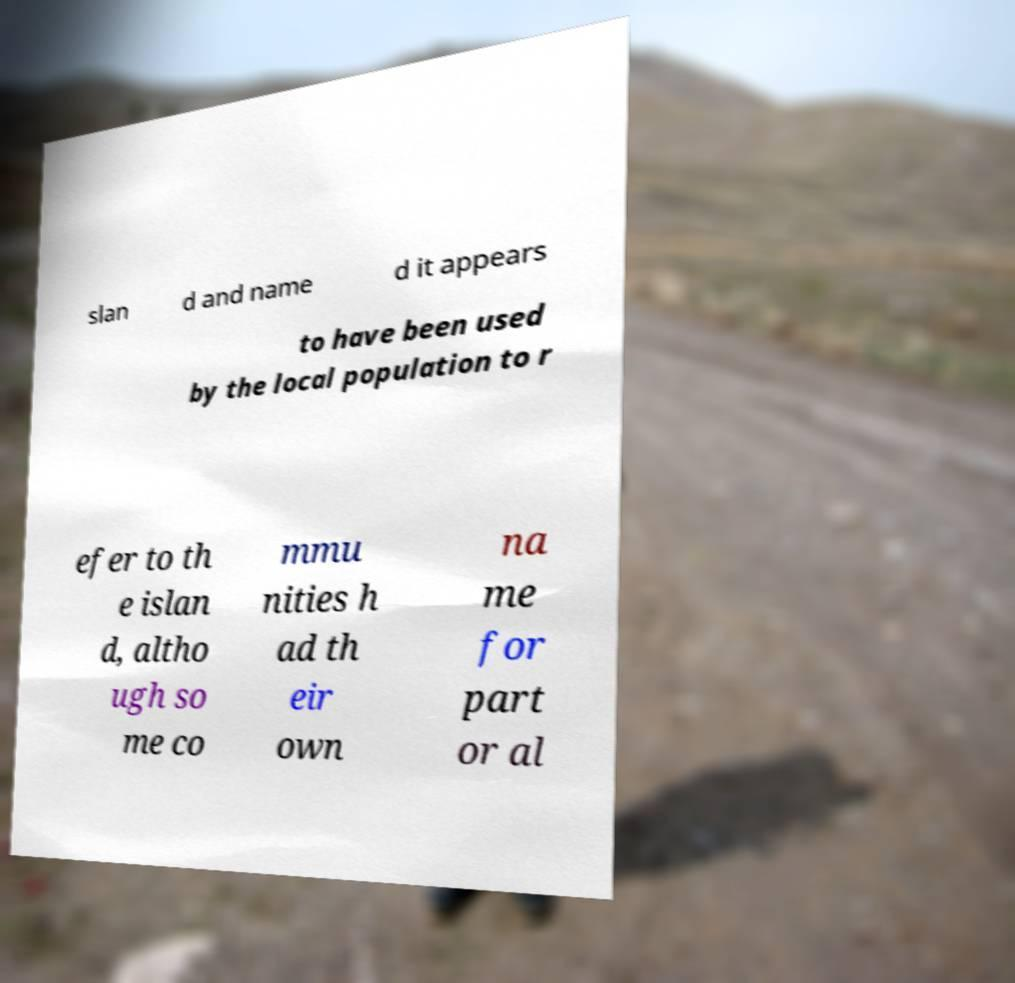Can you accurately transcribe the text from the provided image for me? slan d and name d it appears to have been used by the local population to r efer to th e islan d, altho ugh so me co mmu nities h ad th eir own na me for part or al 